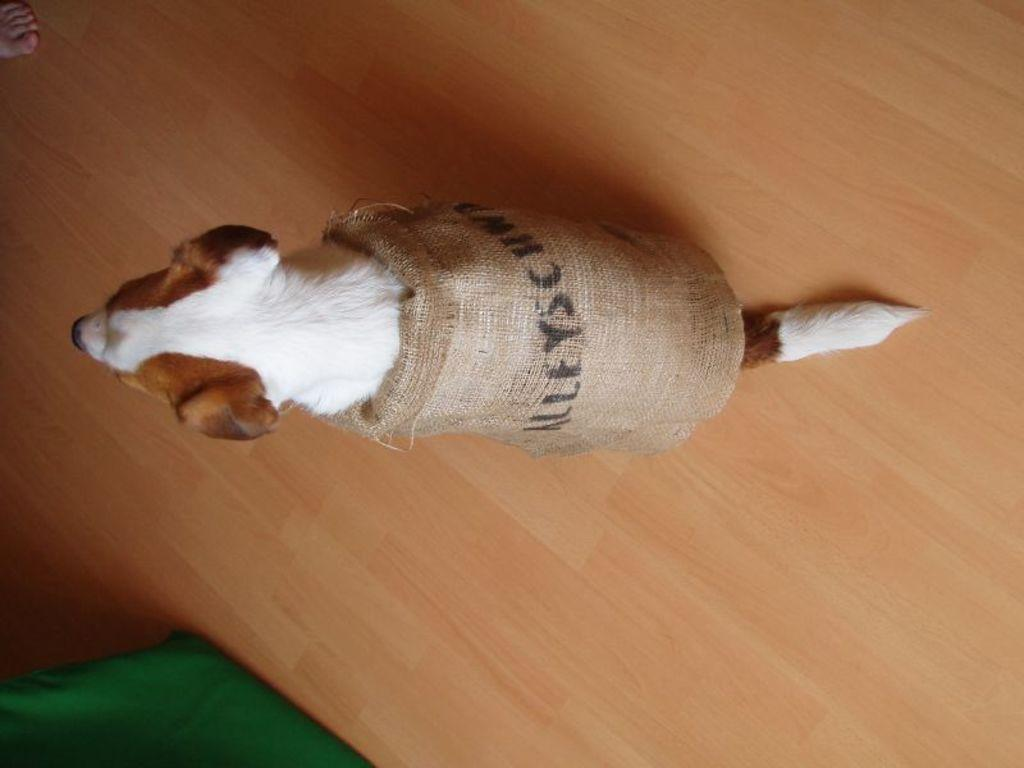What type of animal is in the picture? There is a dog in the picture. Where is the dog located in the image? The dog is sitting on the floor. What is covering the dog in the picture? There is cloth wrapped around the dog. Is there any text or writing on the cloth? Yes, there is text on the cloth. What type of downtown scene can be seen in the background of the image? There is no downtown scene present in the image; it features a dog with cloth wrapped around it. Can you describe the prison where the dog is being held in the image? There is no prison depicted in the image; it shows a dog sitting on the floor with cloth wrapped around it. 